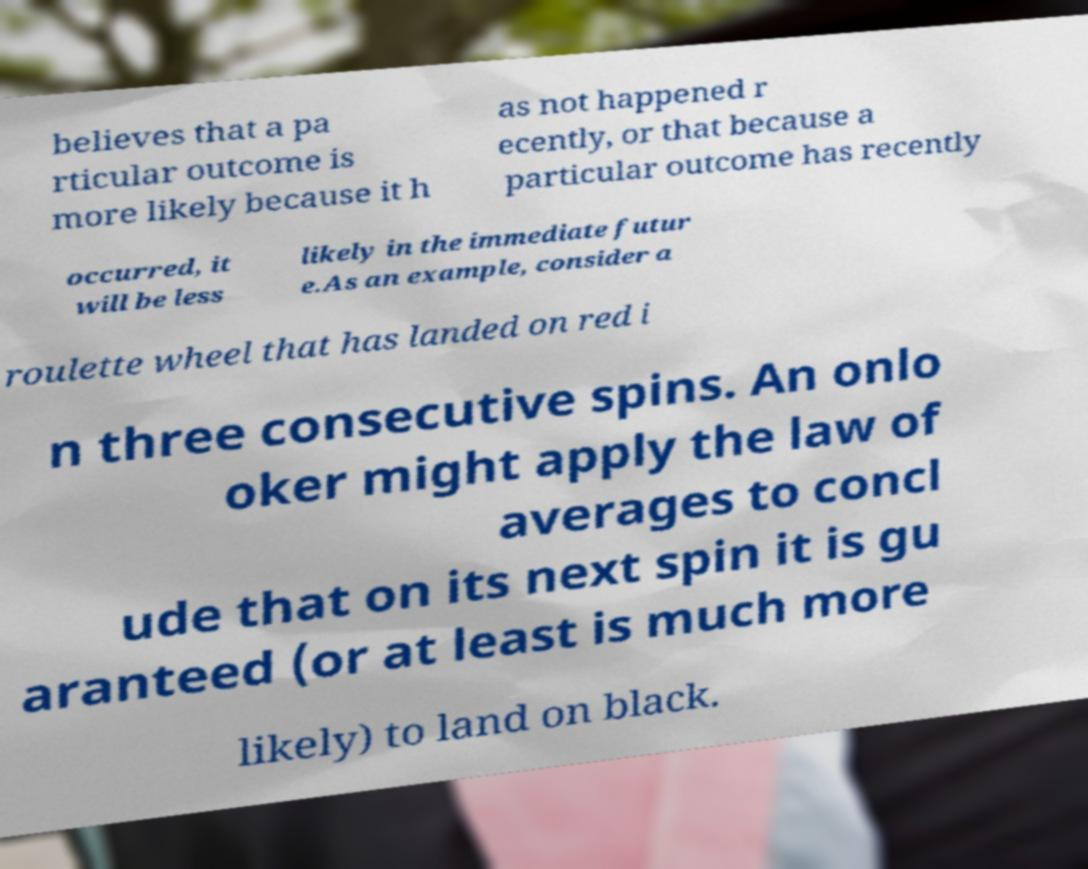Could you extract and type out the text from this image? believes that a pa rticular outcome is more likely because it h as not happened r ecently, or that because a particular outcome has recently occurred, it will be less likely in the immediate futur e.As an example, consider a roulette wheel that has landed on red i n three consecutive spins. An onlo oker might apply the law of averages to concl ude that on its next spin it is gu aranteed (or at least is much more likely) to land on black. 